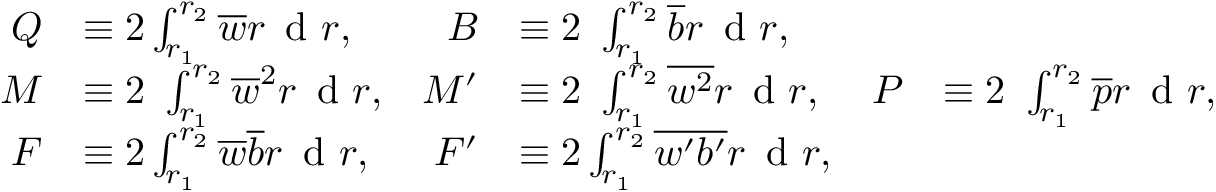Convert formula to latex. <formula><loc_0><loc_0><loc_500><loc_500>\begin{array} { r l r l r l } { Q } & { \equiv 2 \int _ { r _ { 1 } } ^ { r _ { 2 } } \overline { w } r \, d r , } & { B } & { \equiv 2 \ \int _ { r _ { 1 } } ^ { r _ { 2 } } \overline { b } r \, d r , } & \\ { M } & { \equiv 2 \ \int _ { r _ { 1 } } ^ { r _ { 2 } } \overline { w } ^ { 2 } r \, d r , } & { M ^ { \prime } } & { \equiv 2 \ \int _ { r _ { 1 } } ^ { r _ { 2 } } \overline { { w ^ { 2 } } } r \, d r , } & { P } & { \equiv 2 \ \int _ { r _ { 1 } } ^ { r _ { 2 } } \overline { p } r \, d r , } \\ { F } & { \equiv 2 \int _ { r _ { 1 } } ^ { r _ { 2 } } \overline { w } \overline { b } r \, d r , } & { F ^ { \prime } } & { \equiv 2 \int _ { r _ { 1 } } ^ { r _ { 2 } } \overline { { w ^ { \prime } b ^ { \prime } } } r \, d r , } & \end{array}</formula> 